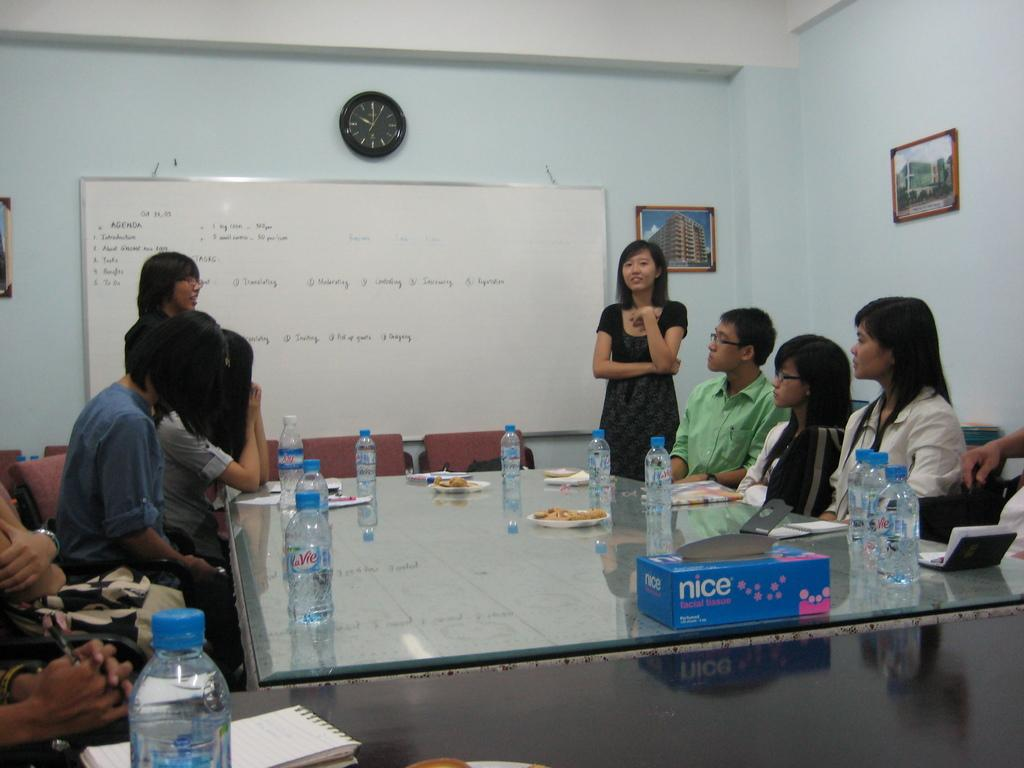Provide a one-sentence caption for the provided image. a blue box with the word nice on it. 